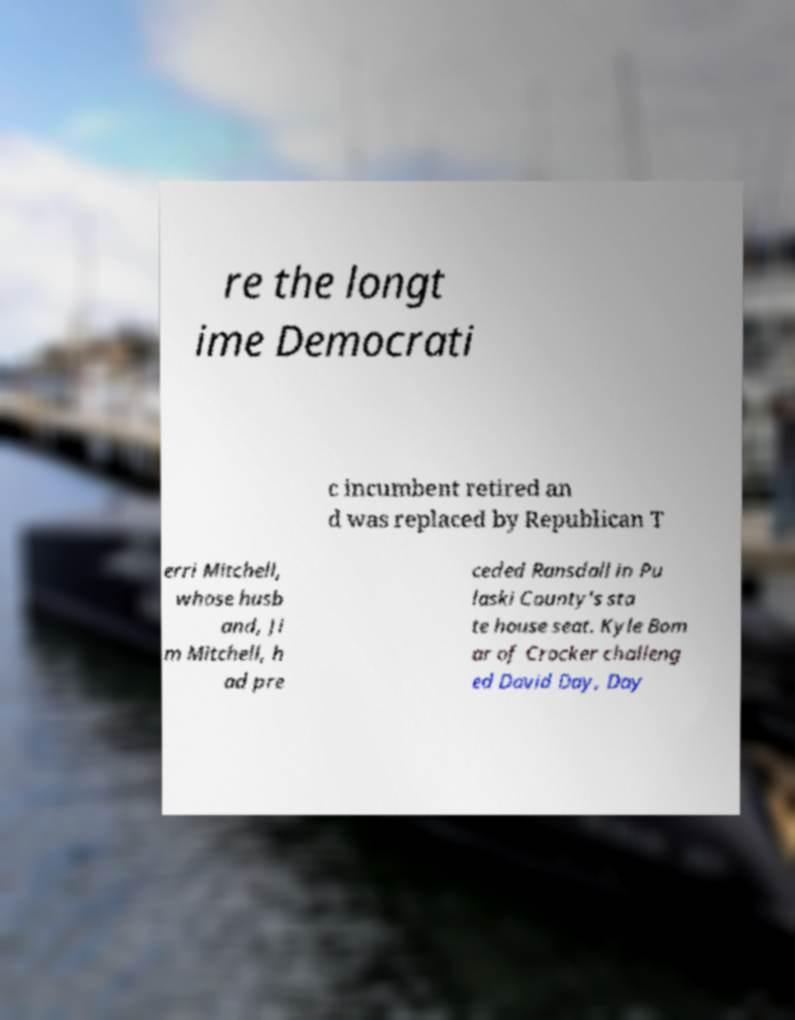For documentation purposes, I need the text within this image transcribed. Could you provide that? re the longt ime Democrati c incumbent retired an d was replaced by Republican T erri Mitchell, whose husb and, Ji m Mitchell, h ad pre ceded Ransdall in Pu laski County's sta te house seat. Kyle Bom ar of Crocker challeng ed David Day, Day 